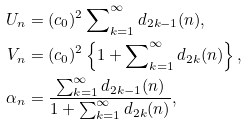Convert formula to latex. <formula><loc_0><loc_0><loc_500><loc_500>U _ { n } & = ( c _ { 0 } ) ^ { 2 } \sum \nolimits _ { k = 1 } ^ { \infty } d _ { 2 k - 1 } ( n ) , \\ V _ { n } & = ( c _ { 0 } ) ^ { 2 } \left \{ 1 + \sum \nolimits _ { k = 1 } ^ { \infty } d _ { 2 k } ( n ) \right \} , \\ \alpha _ { n } & = \frac { \sum _ { k = 1 } ^ { \infty } d _ { 2 k - 1 } ( n ) } { 1 + \sum _ { k = 1 } ^ { \infty } d _ { 2 k } ( n ) } ,</formula> 